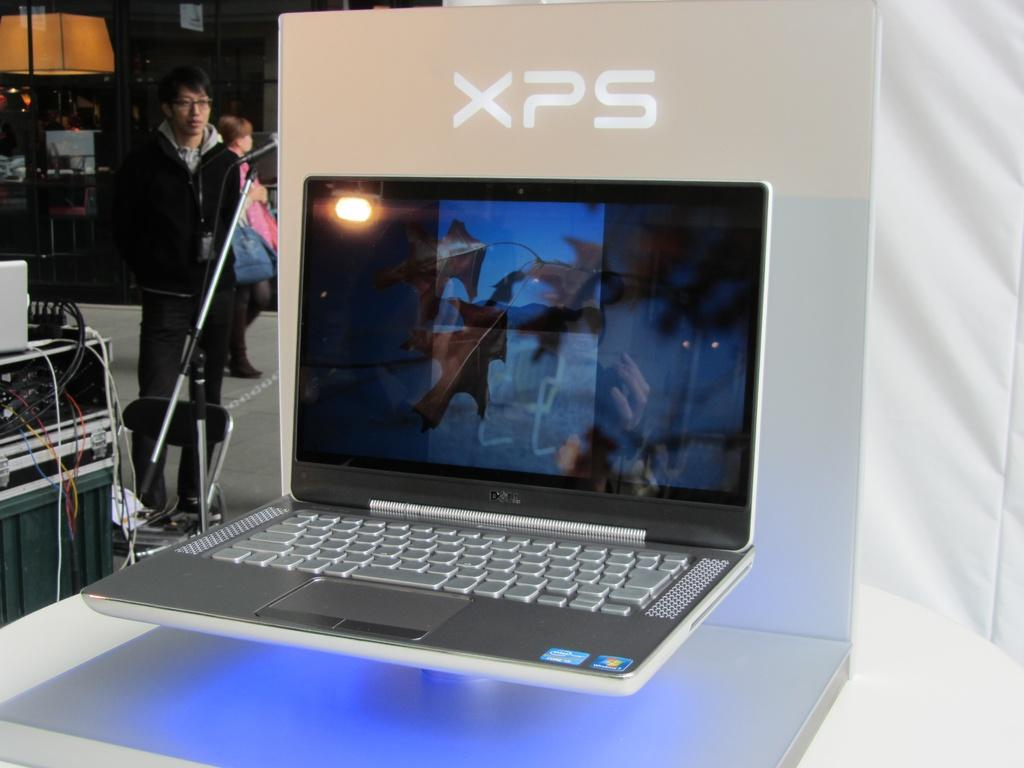<image>
Share a concise interpretation of the image provided. A display of a Dell XPS laptop computer. 